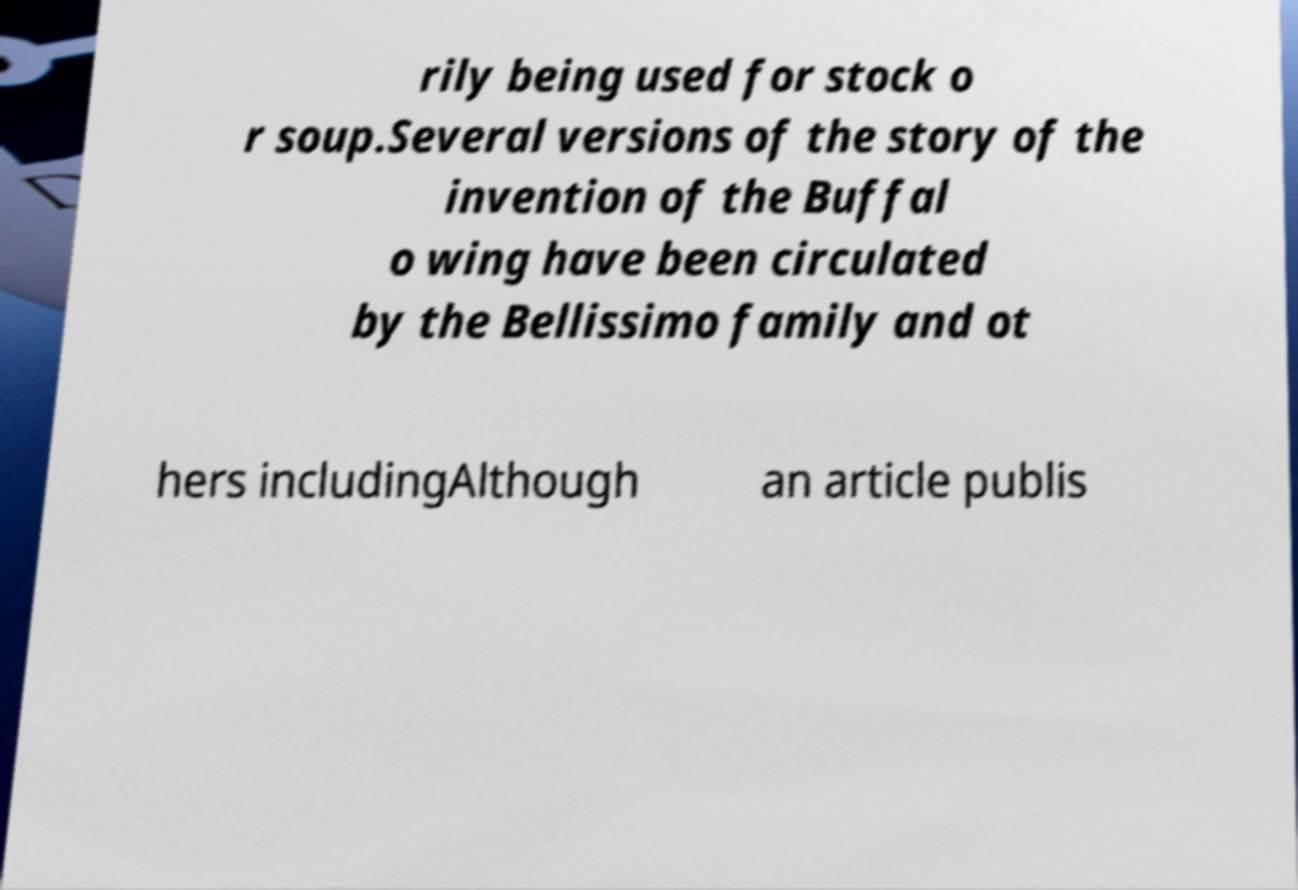Can you read and provide the text displayed in the image?This photo seems to have some interesting text. Can you extract and type it out for me? rily being used for stock o r soup.Several versions of the story of the invention of the Buffal o wing have been circulated by the Bellissimo family and ot hers includingAlthough an article publis 